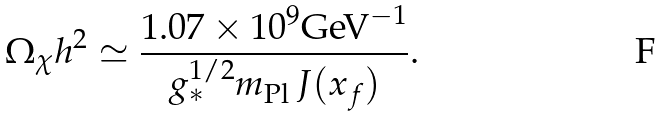Convert formula to latex. <formula><loc_0><loc_0><loc_500><loc_500>\Omega _ { \chi } h ^ { 2 } \simeq \frac { 1 . 0 7 \times 1 0 ^ { 9 } \text {GeV} ^ { - 1 } } { g _ { \ast } ^ { 1 / 2 } m _ { \text {Pl} } \, J ( x _ { f } ) } .</formula> 